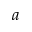<formula> <loc_0><loc_0><loc_500><loc_500>a</formula> 